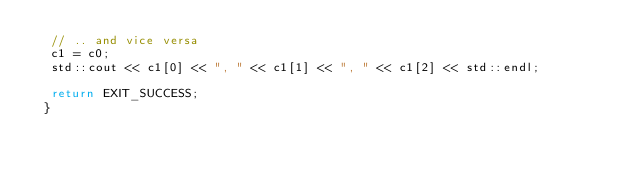<code> <loc_0><loc_0><loc_500><loc_500><_C++_>  // .. and vice versa
  c1 = c0;
  std::cout << c1[0] << ", " << c1[1] << ", " << c1[2] << std::endl;

  return EXIT_SUCCESS;
 }
</code> 